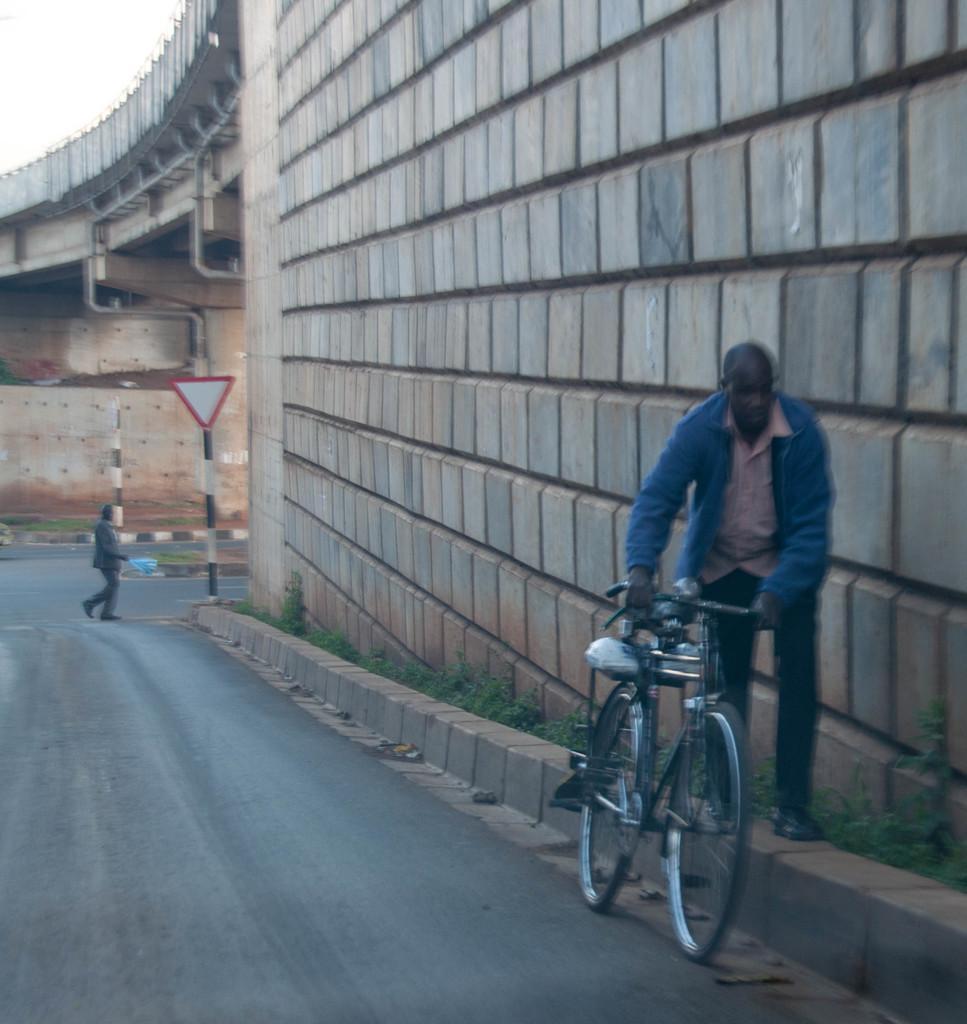In one or two sentences, can you explain what this image depicts? In this picture we can see man wore jacket holding bicycle with his hands and walking on wall and beside to road and other person walking on road and in background we can see wall, sign board, bridge, sky. 